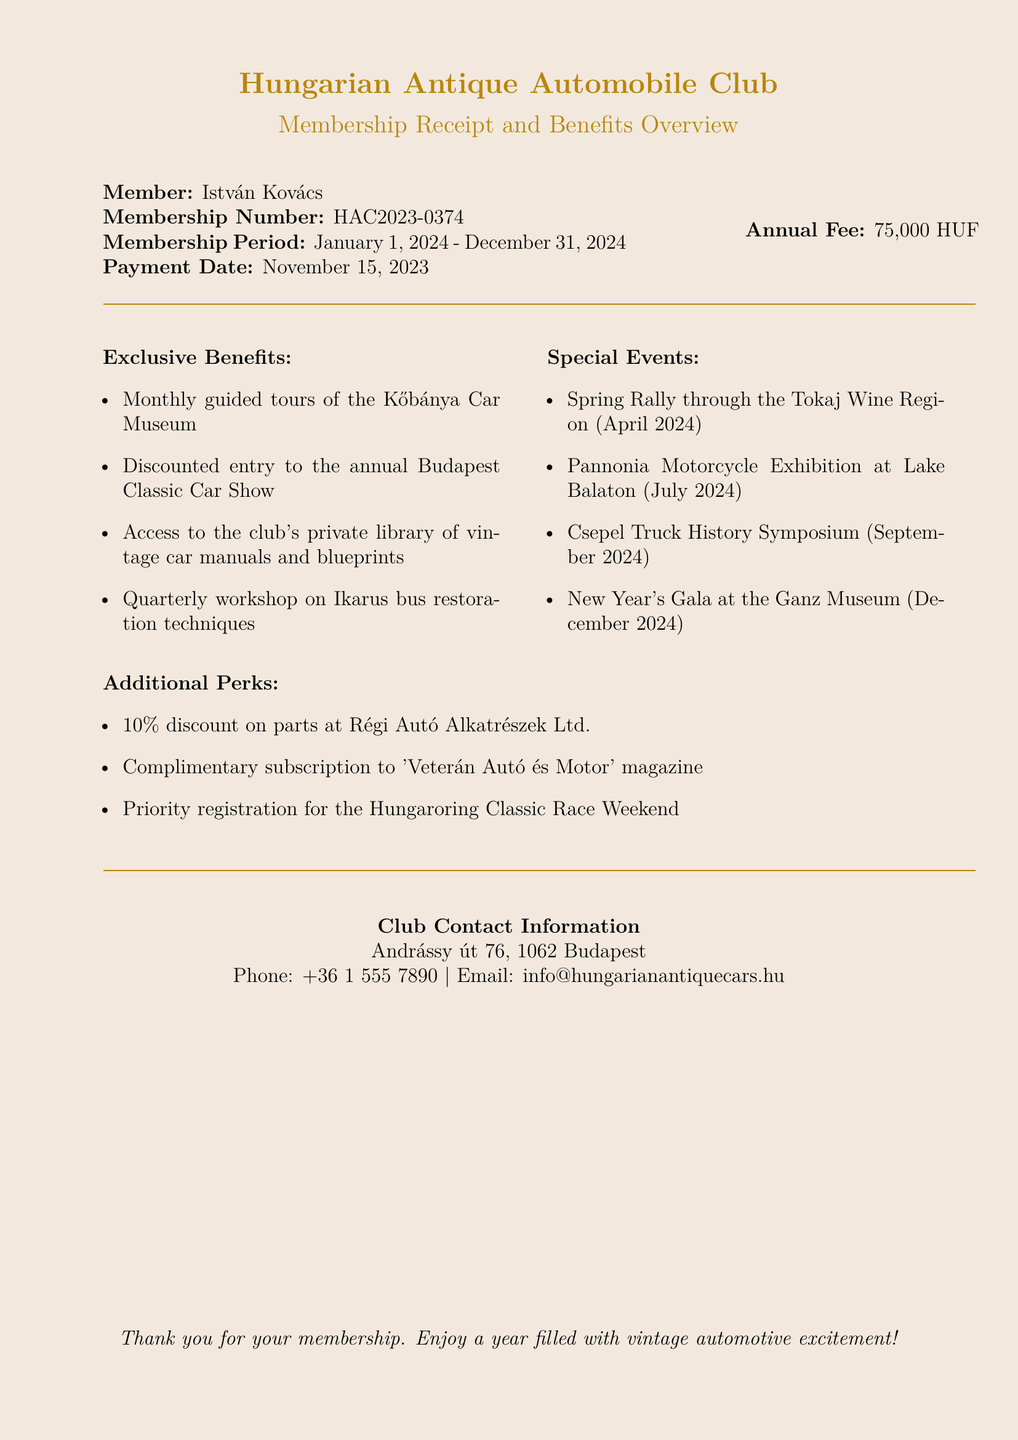What is the member's name? The member's name is presented at the beginning of the document.
Answer: István Kovács What is the membership number? The membership number is specified alongside the member's name.
Answer: HAC2023-0374 What is the annual membership fee? The fee is clearly stated in the financial section of the document.
Answer: 75,000 HUF What is the membership period? The document mentions the duration of the membership.
Answer: January 1, 2024 - December 31, 2024 When was the payment made? The payment date is mentioned directly in the member's details.
Answer: November 15, 2023 Which event occurs in April 2024? This question requires identifying a specific event from the list of special events.
Answer: Spring Rally through the Tokaj Wine Region What discount is offered on parts at a specific store? The discount percentage is specified in the additional perks section.
Answer: 10% What subscription is included as a perk? The document lists benefits, including a subscription name.
Answer: 'Veterán Autó és Motor' magazine What is the address of the club? This information is found in the club contact section of the document.
Answer: Andrássy út 76, 1062 Budapest 